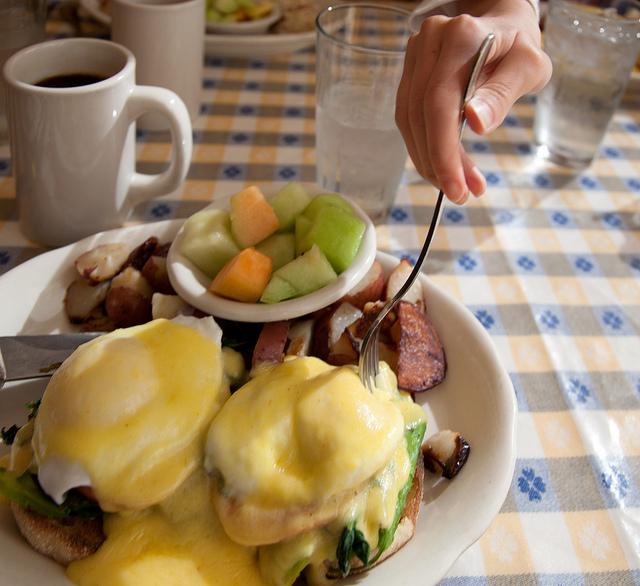What kind of fruit are on the dish?
Give a very brief answer. Melon. Which utensils are visible?
Write a very short answer. Fork. What is the name of the dish being served?
Write a very short answer. Eggs benedict. 